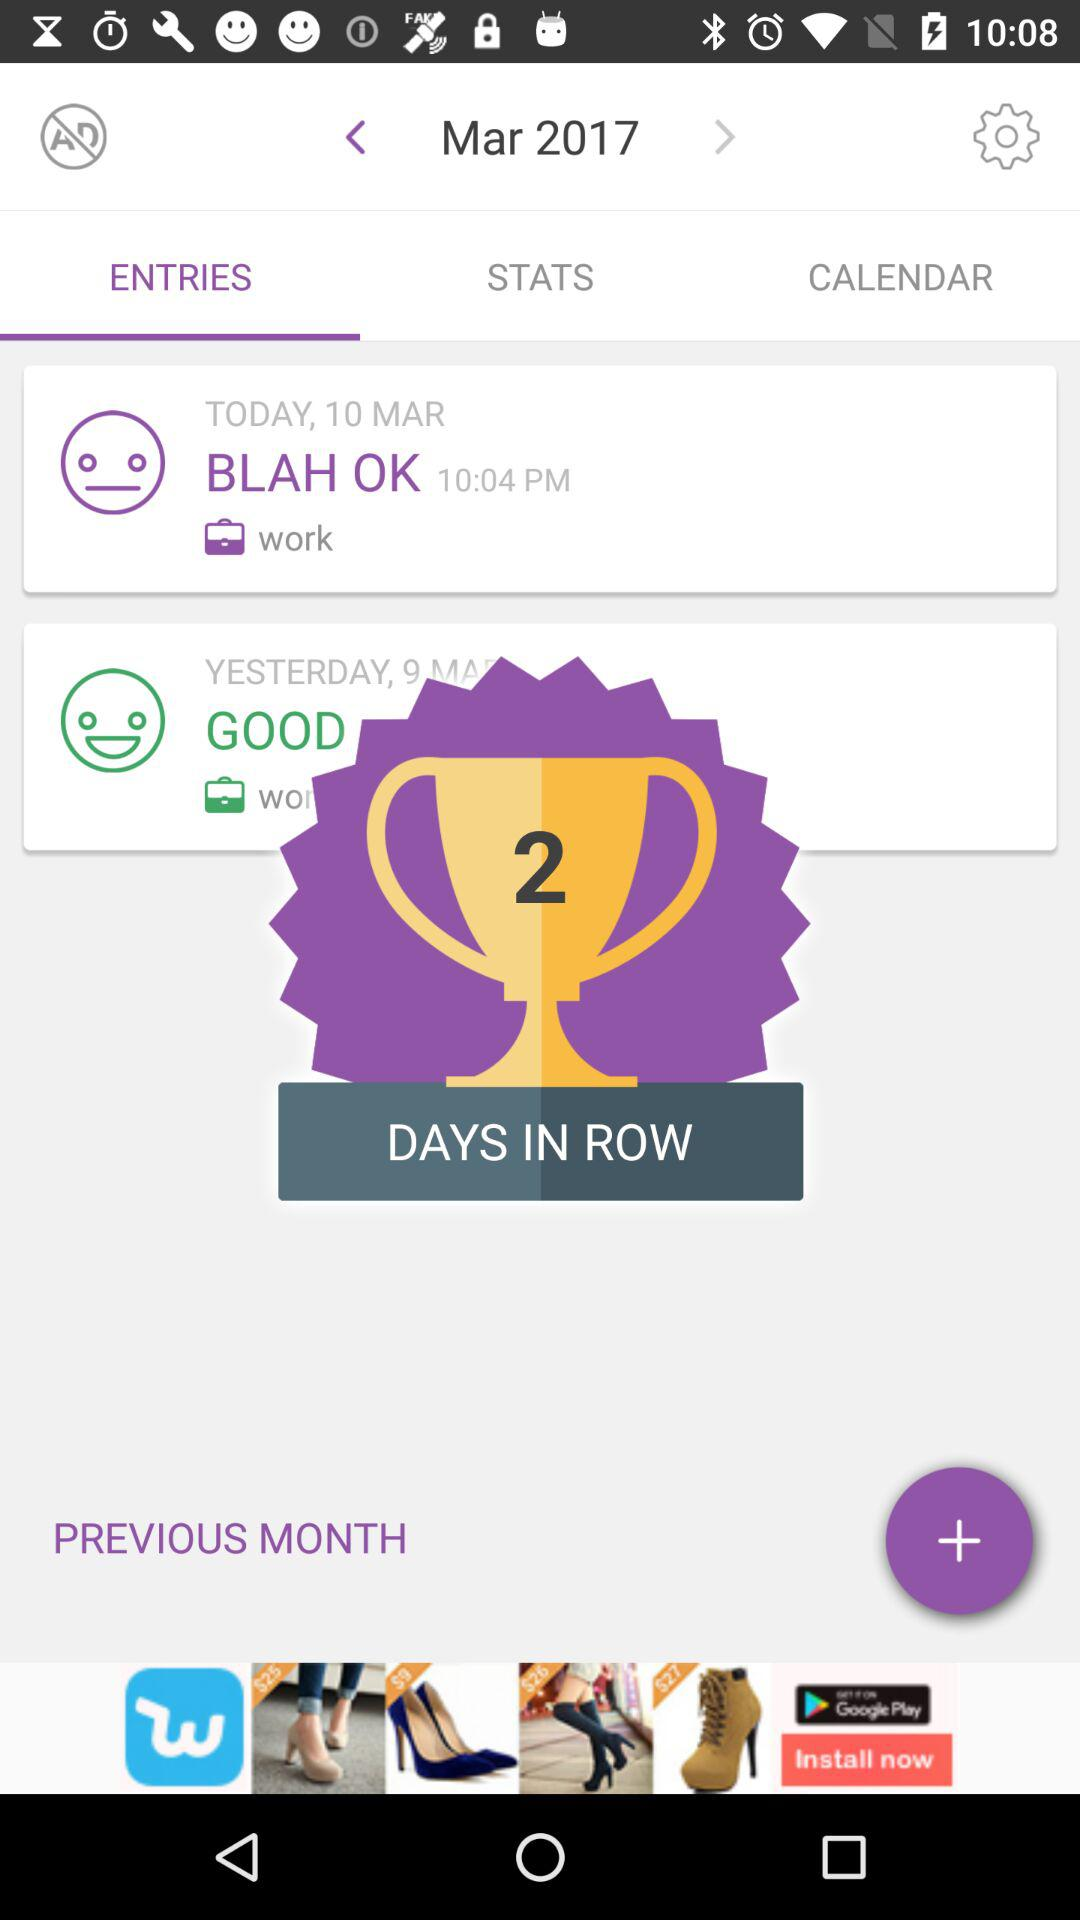How many days in a row have there been entries?
Answer the question using a single word or phrase. 2 